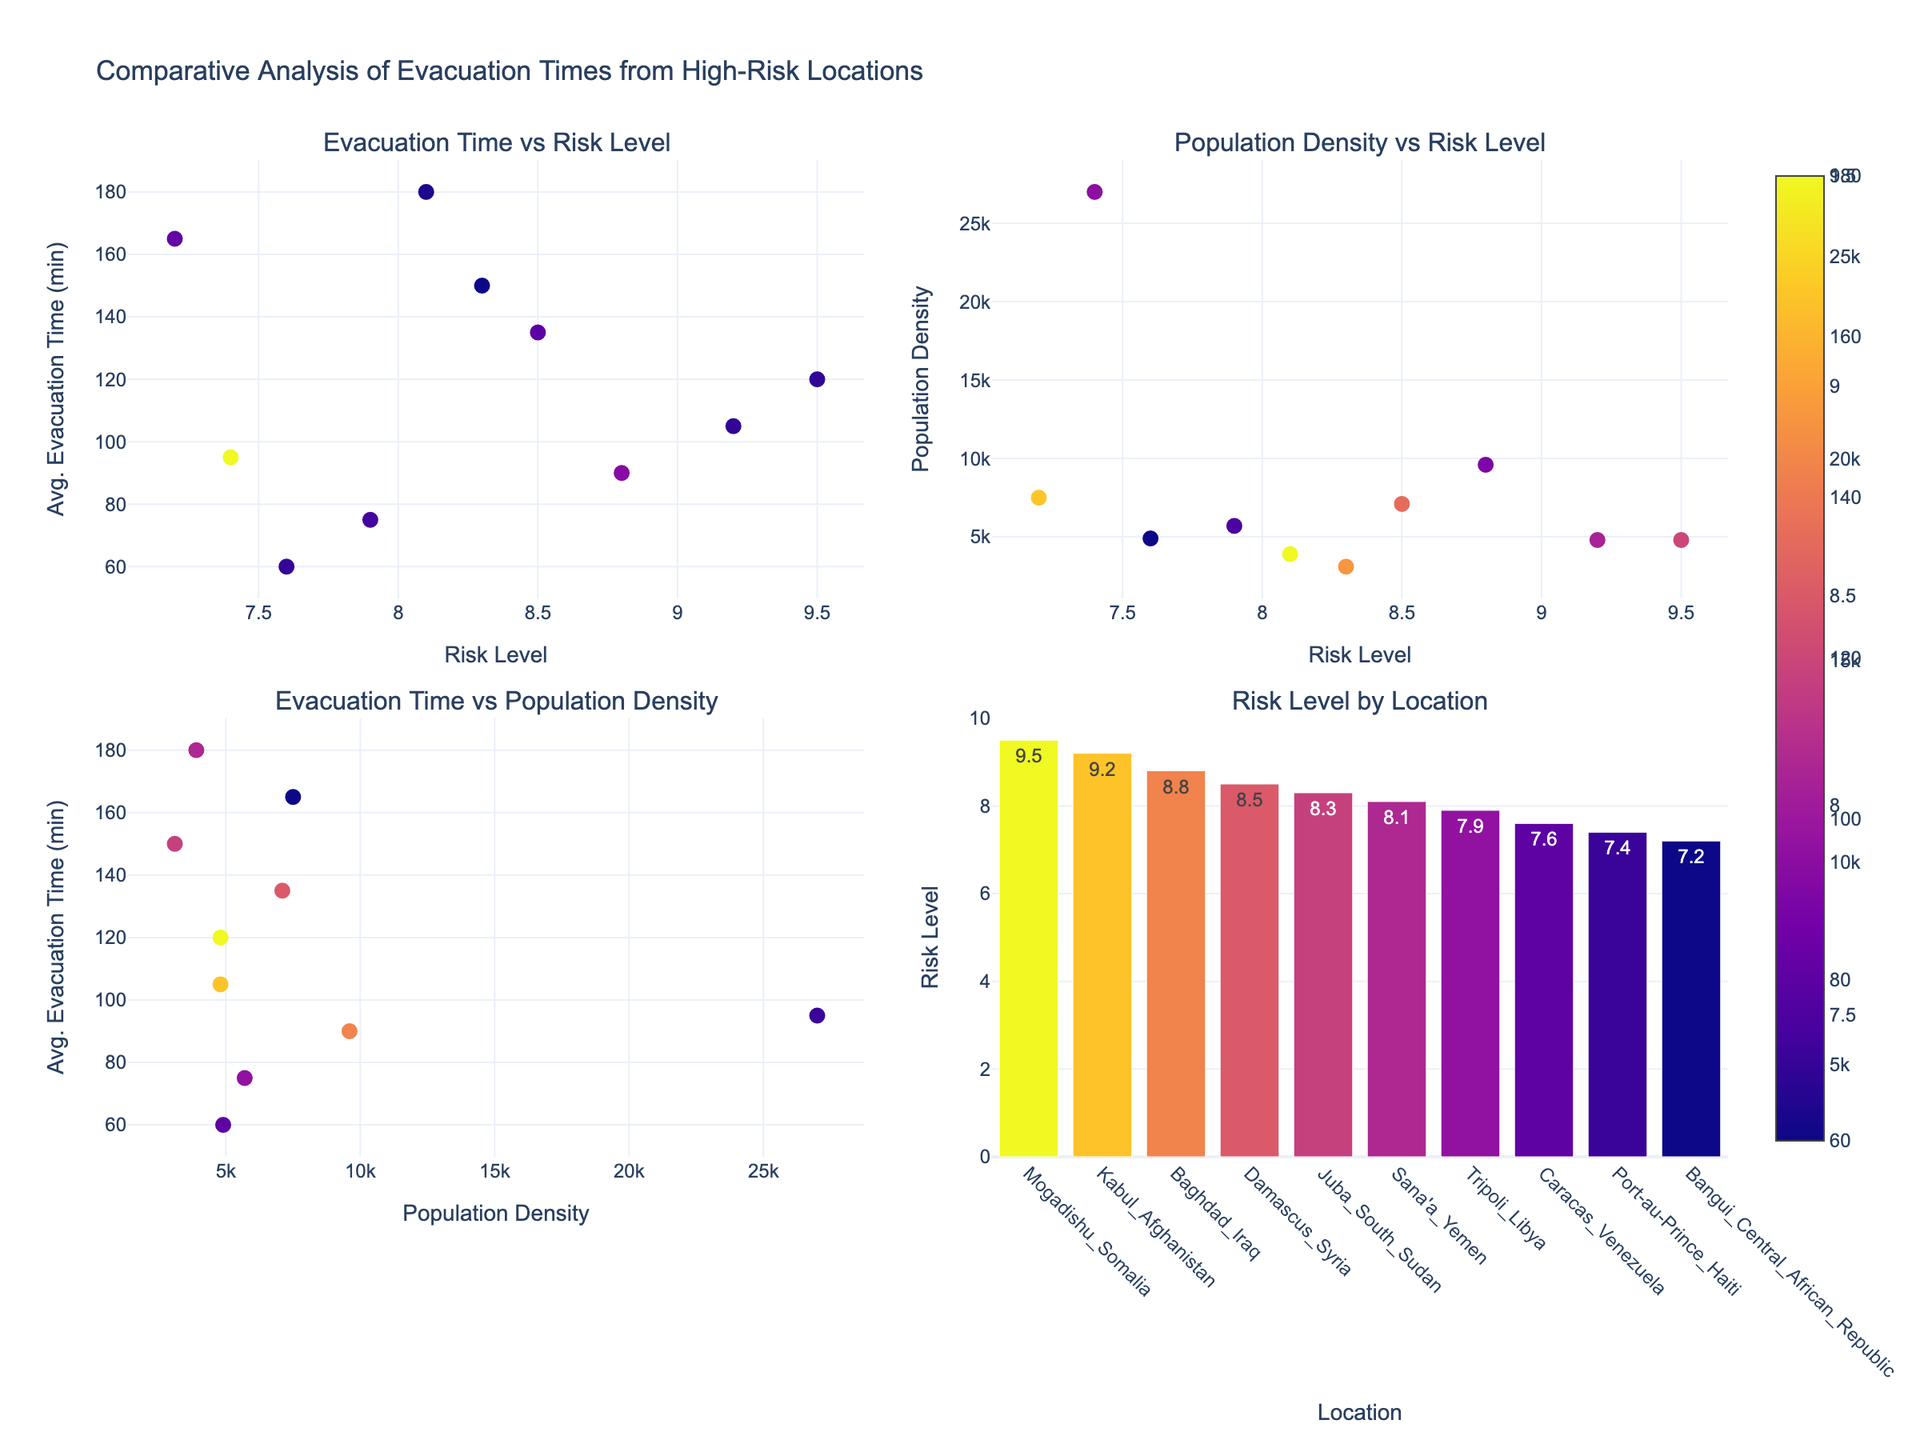What is the title of the plot? The title is typically positioned at the top of the figure. In this case, it clearly mentions "Comparative Analysis of Evacuation Times from High-Risk Locations."
Answer: Comparative Analysis of Evacuation Times from High-Risk Locations How many subplots are there in the figure? The figure is divided into sections, each containing its own graph. The titles of the subplots suggest there are four distinct subplots.
Answer: 4 Which location has the highest risk level? Looking at the bar chart in the bottom right subplot (Risk Level by Location), the bar for Mogadishu_Somalia is the tallest, indicating the highest risk level.
Answer: Mogadishu_Somalia What is the average evacuation time for Tripoli_Libya? Referring to the scatter plots (especially "Evacuation Time vs Risk Level" or "Evacuation Time vs Population Density"), hover info or the y-axis position for Tripoli_Libya can be noted.
Answer: 75 minutes Which location has the lowest population density? Check the values on the y-axis of the "Population Density vs Risk Level" scatter plot and locate the lowest point. Based on the data, this should be Juba_South_Sudan.
Answer: Juba_South_Sudan What is the risk level for Caracas_Venezuela? Using the bar chart in the "Risk Level by Location" subplot, find Caracas_Venezuela and read off its corresponding bar height.
Answer: 7.6 Compare the evacuation times between Juba_South_Sudan and Port-au-Prince_Haiti and identify which one has a longer time. Locate both Juba_South_Sudan and Port-au-Prince_Haiti in the "Evacuation Time vs Risk Level" or "Evacuation Time vs Population Density" scatter plots, then compare their y-values. Juba_South_Sudan (~150 minutes) has a longer evacuation time than Port-au-Prince_Haiti (~95 minutes).
Answer: Juba_South_Sudan Is there a general trend between risk level and average evacuation time? Observing the "Evacuation Time vs Risk Level" subplot, one might note that higher risk levels generally correspond to higher evacuation times, forming a positive correlation overall.
Answer: Positive correlation Which location with a risk level above 8 has the shortest evacuation time? Examine the locations in the risk level by location bar chart with risk levels above 8 and identify the shortest evacuation time from the relevant scatter plots. Tripoli_Libya with a risk level of 7.9 was close but not above 8.
Answer: Baghdad_Iraq In the "Evacuation Time vs Population Density" subplot, what is the population density for Caracas_Venezuela? Locate Caracas_Venezuela in the scatter plot, then trace its position on the x-axis to find the population density value.
Answer: 4900 